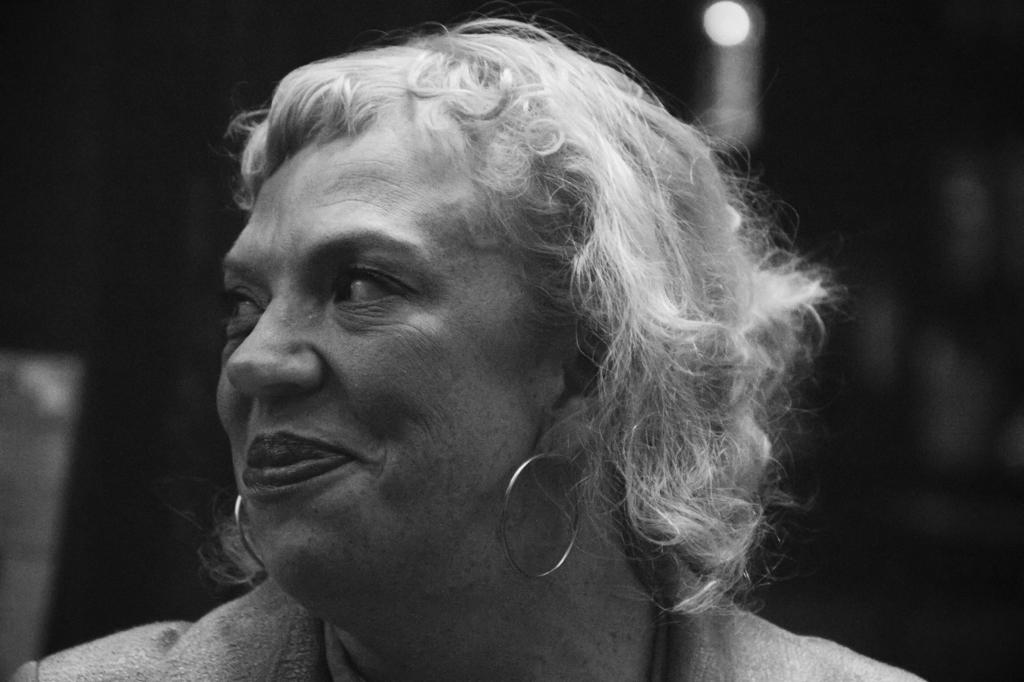Who is the main subject in the image? There is a woman in the image. What is the woman wearing in her ears? The woman is wearing two earrings. How does the woman appear to be feeling in the image? The woman has a smile on her face, suggesting she is happy or content. What is the color scheme of the image? The image is black and white in color. What type of lipstick is the woman wearing in the image? The image is black and white, so it is not possible to determine the type of lipstick the woman might be wearing. Is there any eggnog visible in the image? There is no mention of eggnog in the provided facts, and it is not visible in the image. 